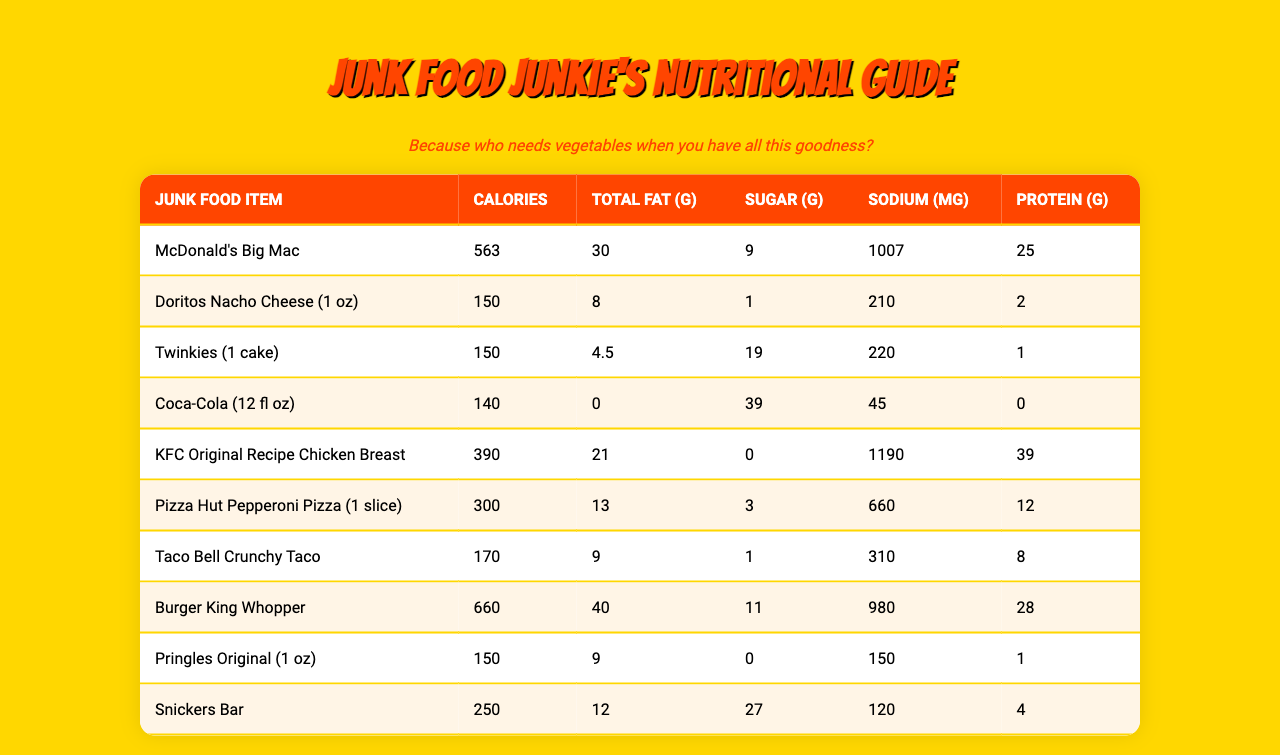What junk food item has the highest calorie content? The calorie content of each item is given in the table. By comparing the values, the Burger King Whopper has the highest calories at 660.
Answer: Burger King Whopper How much total fat is in a Big Mac? According to the table, the Big Mac has a total fat content of 30 grams.
Answer: 30 grams What item has the least sugar? Looking at the sugar content in the table, the Doritos Nacho Cheese states 1 gram of sugar, which is the least among all items listed.
Answer: Doritos Nacho Cheese What is the total amount of protein in KFC Original Recipe Chicken Breast and Snickers Bar combined? The protein content for the KFC Original Recipe Chicken Breast is 39 grams, and for the Snickers Bar, it is 4 grams. Adding those together gives 39 + 4 = 43 grams.
Answer: 43 grams Is the sodium content of a Twinkie greater than that of a Pringles Original? The sodium content for Twinkies is 220 mg, while Pringles contain 150 mg. Since 220 is greater than 150, the statement is true.
Answer: Yes What is the average calorie content of the first three items listed? The first three items are McDonald's Big Mac (563), Doritos Nacho Cheese (150), and Twinkies (150). Adding these gives 563 + 150 + 150 = 863, and dividing by 3 gives an average of 287.67. Rounding gives an average of 288 calories.
Answer: 288 What junk food item has more sugar than sodium? The sugar content of the Twinkies is 19 grams, while the sodium is 220 mg. No other item has high sugar than sodium. Thus, the Twinkie is the one item listed with this comparison.
Answer: Twinkies Which item has the highest total fat, and how much is it? Reviewing the total fat column, the Burger King Whopper has 40 grams, which is the most when comparing all listed items.
Answer: Burger King Whopper, 40 grams What is the difference in calories between the Whopper and the Big Mac? The calorie content of the Whopper is 660, and the Big Mac is 563. The difference is calculated as 660 - 563 = 97.
Answer: 97 calories How many grams of total fat does Pizza Hut Pepperoni Pizza have, and is it more than that of the Doritos? The Pizza Hut Pepperoni Pizza has 13 grams of fat while the Doritos have 8 grams. Since 13 is greater than 8, the comparison holds true.
Answer: Yes 